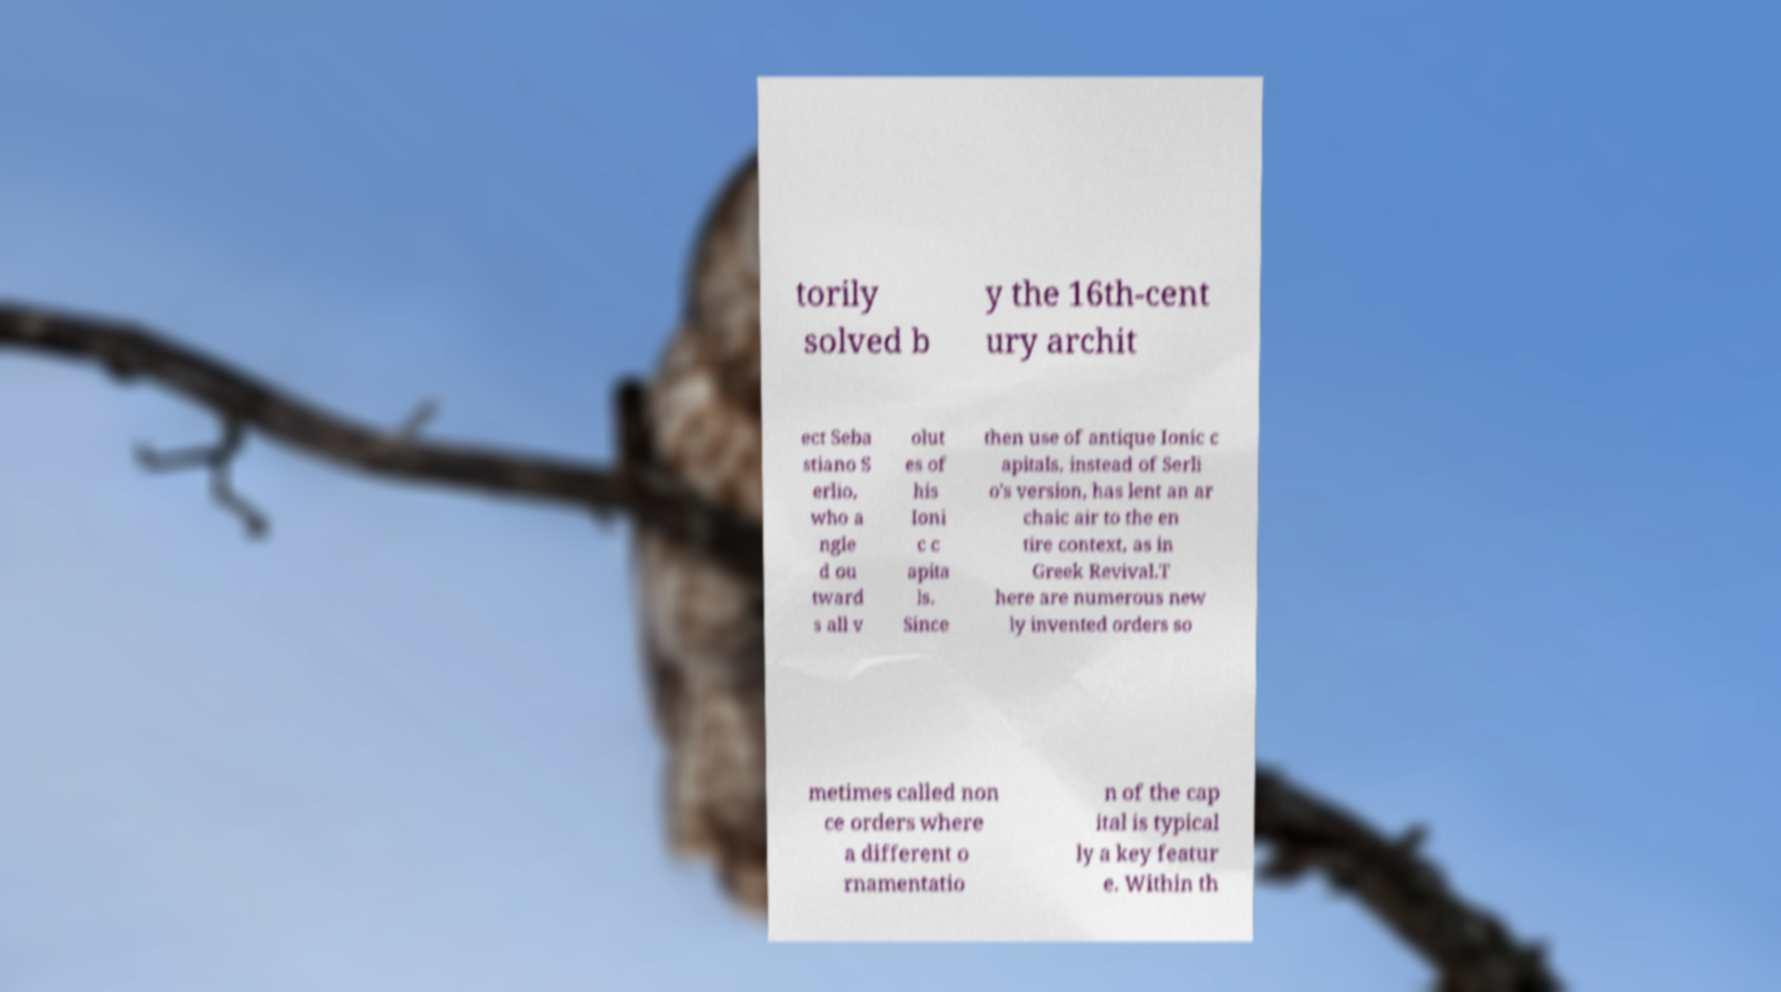I need the written content from this picture converted into text. Can you do that? torily solved b y the 16th-cent ury archit ect Seba stiano S erlio, who a ngle d ou tward s all v olut es of his Ioni c c apita ls. Since then use of antique Ionic c apitals, instead of Serli o's version, has lent an ar chaic air to the en tire context, as in Greek Revival.T here are numerous new ly invented orders so metimes called non ce orders where a different o rnamentatio n of the cap ital is typical ly a key featur e. Within th 